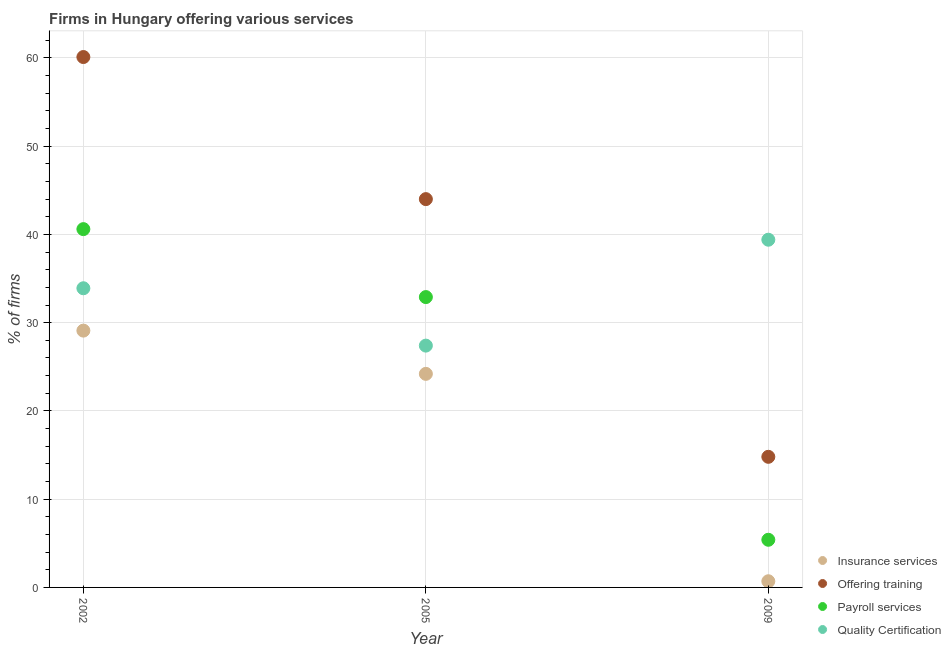Is the number of dotlines equal to the number of legend labels?
Offer a terse response. Yes. What is the percentage of firms offering insurance services in 2002?
Keep it short and to the point. 29.1. Across all years, what is the maximum percentage of firms offering training?
Offer a very short reply. 60.1. What is the total percentage of firms offering training in the graph?
Make the answer very short. 118.9. What is the difference between the percentage of firms offering insurance services in 2002 and the percentage of firms offering training in 2005?
Give a very brief answer. -14.9. What is the average percentage of firms offering insurance services per year?
Make the answer very short. 18. In the year 2005, what is the difference between the percentage of firms offering payroll services and percentage of firms offering insurance services?
Ensure brevity in your answer.  8.7. What is the ratio of the percentage of firms offering quality certification in 2005 to that in 2009?
Make the answer very short. 0.7. Is the percentage of firms offering quality certification in 2002 less than that in 2009?
Keep it short and to the point. Yes. Is the difference between the percentage of firms offering quality certification in 2002 and 2005 greater than the difference between the percentage of firms offering payroll services in 2002 and 2005?
Provide a succinct answer. No. What is the difference between the highest and the second highest percentage of firms offering training?
Your answer should be very brief. 16.1. What is the difference between the highest and the lowest percentage of firms offering training?
Your answer should be very brief. 45.3. In how many years, is the percentage of firms offering insurance services greater than the average percentage of firms offering insurance services taken over all years?
Provide a short and direct response. 2. Is the sum of the percentage of firms offering insurance services in 2005 and 2009 greater than the maximum percentage of firms offering training across all years?
Your response must be concise. No. Is it the case that in every year, the sum of the percentage of firms offering insurance services and percentage of firms offering training is greater than the percentage of firms offering payroll services?
Provide a short and direct response. Yes. Does the percentage of firms offering training monotonically increase over the years?
Give a very brief answer. No. Is the percentage of firms offering insurance services strictly greater than the percentage of firms offering training over the years?
Your response must be concise. No. What is the difference between two consecutive major ticks on the Y-axis?
Your answer should be very brief. 10. Are the values on the major ticks of Y-axis written in scientific E-notation?
Provide a succinct answer. No. Does the graph contain any zero values?
Provide a succinct answer. No. Does the graph contain grids?
Your answer should be compact. Yes. How many legend labels are there?
Offer a very short reply. 4. What is the title of the graph?
Make the answer very short. Firms in Hungary offering various services . What is the label or title of the X-axis?
Ensure brevity in your answer.  Year. What is the label or title of the Y-axis?
Give a very brief answer. % of firms. What is the % of firms of Insurance services in 2002?
Provide a succinct answer. 29.1. What is the % of firms in Offering training in 2002?
Give a very brief answer. 60.1. What is the % of firms in Payroll services in 2002?
Offer a terse response. 40.6. What is the % of firms in Quality Certification in 2002?
Provide a short and direct response. 33.9. What is the % of firms in Insurance services in 2005?
Provide a short and direct response. 24.2. What is the % of firms of Payroll services in 2005?
Keep it short and to the point. 32.9. What is the % of firms of Quality Certification in 2005?
Keep it short and to the point. 27.4. What is the % of firms in Insurance services in 2009?
Make the answer very short. 0.7. What is the % of firms of Payroll services in 2009?
Your response must be concise. 5.4. What is the % of firms of Quality Certification in 2009?
Provide a short and direct response. 39.4. Across all years, what is the maximum % of firms of Insurance services?
Your response must be concise. 29.1. Across all years, what is the maximum % of firms in Offering training?
Your answer should be compact. 60.1. Across all years, what is the maximum % of firms in Payroll services?
Ensure brevity in your answer.  40.6. Across all years, what is the maximum % of firms of Quality Certification?
Your answer should be compact. 39.4. Across all years, what is the minimum % of firms in Offering training?
Make the answer very short. 14.8. Across all years, what is the minimum % of firms in Payroll services?
Give a very brief answer. 5.4. Across all years, what is the minimum % of firms of Quality Certification?
Your response must be concise. 27.4. What is the total % of firms in Offering training in the graph?
Keep it short and to the point. 118.9. What is the total % of firms in Payroll services in the graph?
Provide a short and direct response. 78.9. What is the total % of firms in Quality Certification in the graph?
Offer a terse response. 100.7. What is the difference between the % of firms in Payroll services in 2002 and that in 2005?
Provide a succinct answer. 7.7. What is the difference between the % of firms of Insurance services in 2002 and that in 2009?
Give a very brief answer. 28.4. What is the difference between the % of firms in Offering training in 2002 and that in 2009?
Offer a very short reply. 45.3. What is the difference between the % of firms of Payroll services in 2002 and that in 2009?
Provide a short and direct response. 35.2. What is the difference between the % of firms in Insurance services in 2005 and that in 2009?
Your answer should be compact. 23.5. What is the difference between the % of firms in Offering training in 2005 and that in 2009?
Ensure brevity in your answer.  29.2. What is the difference between the % of firms in Payroll services in 2005 and that in 2009?
Give a very brief answer. 27.5. What is the difference between the % of firms of Insurance services in 2002 and the % of firms of Offering training in 2005?
Make the answer very short. -14.9. What is the difference between the % of firms of Offering training in 2002 and the % of firms of Payroll services in 2005?
Your answer should be very brief. 27.2. What is the difference between the % of firms in Offering training in 2002 and the % of firms in Quality Certification in 2005?
Provide a short and direct response. 32.7. What is the difference between the % of firms in Insurance services in 2002 and the % of firms in Offering training in 2009?
Provide a short and direct response. 14.3. What is the difference between the % of firms of Insurance services in 2002 and the % of firms of Payroll services in 2009?
Give a very brief answer. 23.7. What is the difference between the % of firms of Offering training in 2002 and the % of firms of Payroll services in 2009?
Your answer should be compact. 54.7. What is the difference between the % of firms in Offering training in 2002 and the % of firms in Quality Certification in 2009?
Provide a short and direct response. 20.7. What is the difference between the % of firms of Payroll services in 2002 and the % of firms of Quality Certification in 2009?
Provide a succinct answer. 1.2. What is the difference between the % of firms of Insurance services in 2005 and the % of firms of Payroll services in 2009?
Your answer should be compact. 18.8. What is the difference between the % of firms of Insurance services in 2005 and the % of firms of Quality Certification in 2009?
Keep it short and to the point. -15.2. What is the difference between the % of firms of Offering training in 2005 and the % of firms of Payroll services in 2009?
Provide a short and direct response. 38.6. What is the difference between the % of firms in Offering training in 2005 and the % of firms in Quality Certification in 2009?
Your response must be concise. 4.6. What is the difference between the % of firms in Payroll services in 2005 and the % of firms in Quality Certification in 2009?
Ensure brevity in your answer.  -6.5. What is the average % of firms of Insurance services per year?
Offer a very short reply. 18. What is the average % of firms of Offering training per year?
Your answer should be compact. 39.63. What is the average % of firms in Payroll services per year?
Provide a succinct answer. 26.3. What is the average % of firms of Quality Certification per year?
Your response must be concise. 33.57. In the year 2002, what is the difference between the % of firms of Insurance services and % of firms of Offering training?
Make the answer very short. -31. In the year 2002, what is the difference between the % of firms in Insurance services and % of firms in Payroll services?
Your response must be concise. -11.5. In the year 2002, what is the difference between the % of firms of Insurance services and % of firms of Quality Certification?
Keep it short and to the point. -4.8. In the year 2002, what is the difference between the % of firms in Offering training and % of firms in Payroll services?
Provide a succinct answer. 19.5. In the year 2002, what is the difference between the % of firms of Offering training and % of firms of Quality Certification?
Make the answer very short. 26.2. In the year 2002, what is the difference between the % of firms of Payroll services and % of firms of Quality Certification?
Ensure brevity in your answer.  6.7. In the year 2005, what is the difference between the % of firms in Insurance services and % of firms in Offering training?
Provide a succinct answer. -19.8. In the year 2005, what is the difference between the % of firms in Offering training and % of firms in Payroll services?
Keep it short and to the point. 11.1. In the year 2005, what is the difference between the % of firms of Offering training and % of firms of Quality Certification?
Make the answer very short. 16.6. In the year 2009, what is the difference between the % of firms in Insurance services and % of firms in Offering training?
Offer a terse response. -14.1. In the year 2009, what is the difference between the % of firms of Insurance services and % of firms of Payroll services?
Keep it short and to the point. -4.7. In the year 2009, what is the difference between the % of firms of Insurance services and % of firms of Quality Certification?
Provide a succinct answer. -38.7. In the year 2009, what is the difference between the % of firms in Offering training and % of firms in Quality Certification?
Offer a very short reply. -24.6. In the year 2009, what is the difference between the % of firms in Payroll services and % of firms in Quality Certification?
Offer a terse response. -34. What is the ratio of the % of firms in Insurance services in 2002 to that in 2005?
Make the answer very short. 1.2. What is the ratio of the % of firms in Offering training in 2002 to that in 2005?
Ensure brevity in your answer.  1.37. What is the ratio of the % of firms of Payroll services in 2002 to that in 2005?
Offer a terse response. 1.23. What is the ratio of the % of firms of Quality Certification in 2002 to that in 2005?
Ensure brevity in your answer.  1.24. What is the ratio of the % of firms in Insurance services in 2002 to that in 2009?
Provide a short and direct response. 41.57. What is the ratio of the % of firms in Offering training in 2002 to that in 2009?
Offer a terse response. 4.06. What is the ratio of the % of firms in Payroll services in 2002 to that in 2009?
Ensure brevity in your answer.  7.52. What is the ratio of the % of firms in Quality Certification in 2002 to that in 2009?
Keep it short and to the point. 0.86. What is the ratio of the % of firms of Insurance services in 2005 to that in 2009?
Keep it short and to the point. 34.57. What is the ratio of the % of firms in Offering training in 2005 to that in 2009?
Give a very brief answer. 2.97. What is the ratio of the % of firms of Payroll services in 2005 to that in 2009?
Make the answer very short. 6.09. What is the ratio of the % of firms in Quality Certification in 2005 to that in 2009?
Offer a terse response. 0.7. What is the difference between the highest and the second highest % of firms in Insurance services?
Your response must be concise. 4.9. What is the difference between the highest and the second highest % of firms of Offering training?
Ensure brevity in your answer.  16.1. What is the difference between the highest and the second highest % of firms in Payroll services?
Keep it short and to the point. 7.7. What is the difference between the highest and the lowest % of firms in Insurance services?
Keep it short and to the point. 28.4. What is the difference between the highest and the lowest % of firms in Offering training?
Offer a terse response. 45.3. What is the difference between the highest and the lowest % of firms in Payroll services?
Your answer should be compact. 35.2. What is the difference between the highest and the lowest % of firms in Quality Certification?
Provide a succinct answer. 12. 